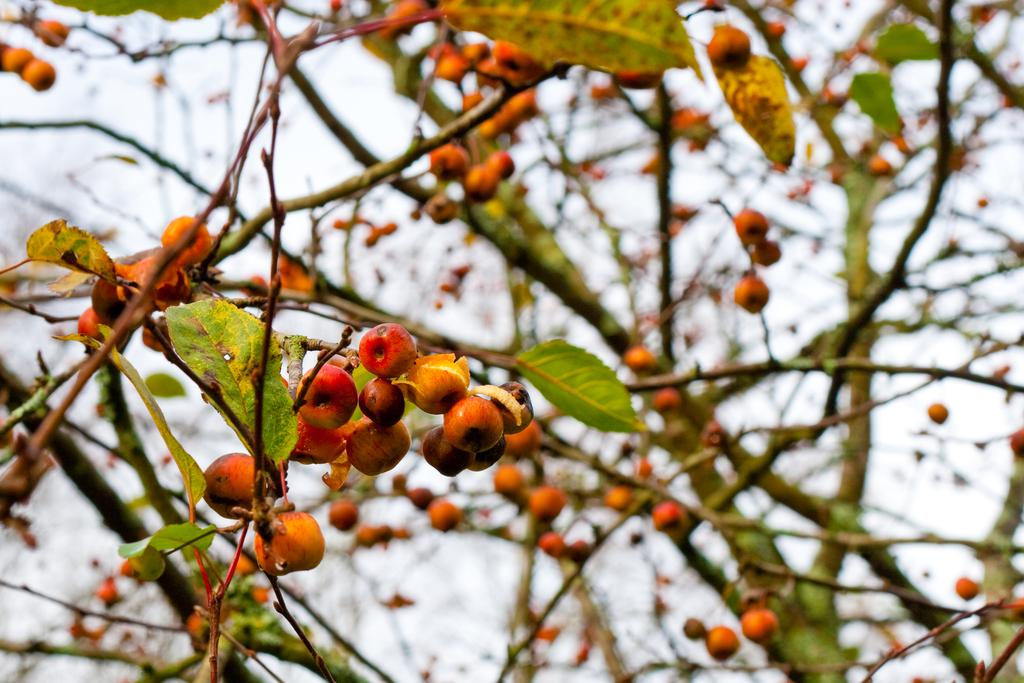What type of vegetation is present in the image? There are trees with fruits in the image. What can be seen in the background of the image? The sky is visible in the image. What songs are being sung by the trees in the image? Trees do not sing songs, so there are no songs being sung by the trees in the image. 